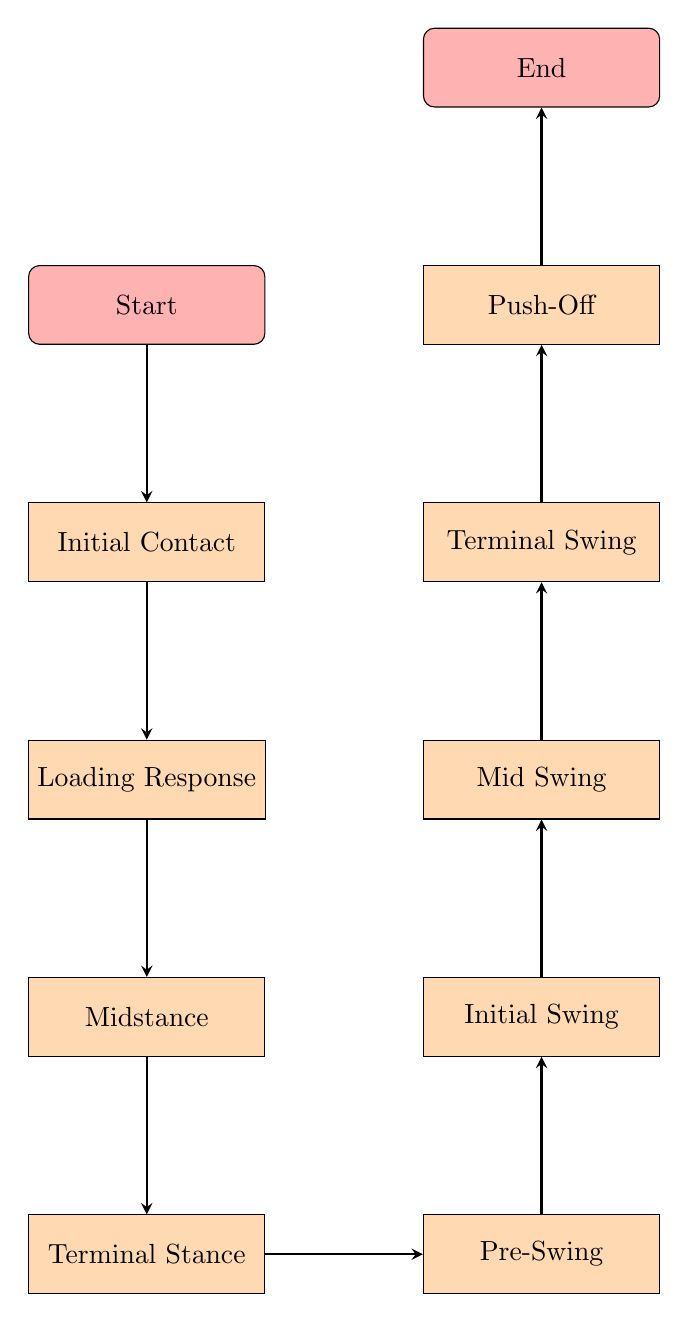What is the starting point of the gait analysis? The starting point is labeled as "Start" in the diagram. It is the first node in the flow chart.
Answer: Start How many total nodes are present in this flow chart? By counting each unique labeled node, there are a total of 11 nodes in the diagram.
Answer: 11 What is the label of the node that follows Midstance? The node that follows Midstance, indicated by the arrow in the flow chart, is labeled "Terminal Stance."
Answer: Terminal Stance Which phase comes right before Push-Off? The phase right before Push-Off is indicated as "Terminal Swing," which directly precedes it in the flow chart.
Answer: Terminal Swing What is the last phase of gait analysis? The last phase, as shown at the top of the flow chart, is labeled "End."
Answer: End Which two phases are directly linked to Pre-Swing? Pre-Swing is linked to the phases "Terminal Stance" and "Initial Swing" in the flow chart, preceding and following it respectively.
Answer: Terminal Stance and Initial Swing What is the relationship between Initial Contact and Loading Response? Initial Contact directly flows into Loading Response according to the arrows in the diagram, indicating that Loading Response occurs after Initial Contact.
Answer: Loading Response follows Initial Contact How does the analysis progress from Push-Off? After Push-Off, the analysis progresses to the "End" of the gait analysis, indicating a conclusion to that series of movement patterns.
Answer: Progresses to End What is analyzed during the Initial Swing phase? The analysis during Initial Swing is focused on the moment when the foot leaves the ground and the knee begins to flex.
Answer: Foot leaves the ground and knee flexes Which phase evaluates body alignment? The phase that evaluates the stabilization of the foot and body alignment is labeled "Midstance" in the flow chart.
Answer: Midstance 